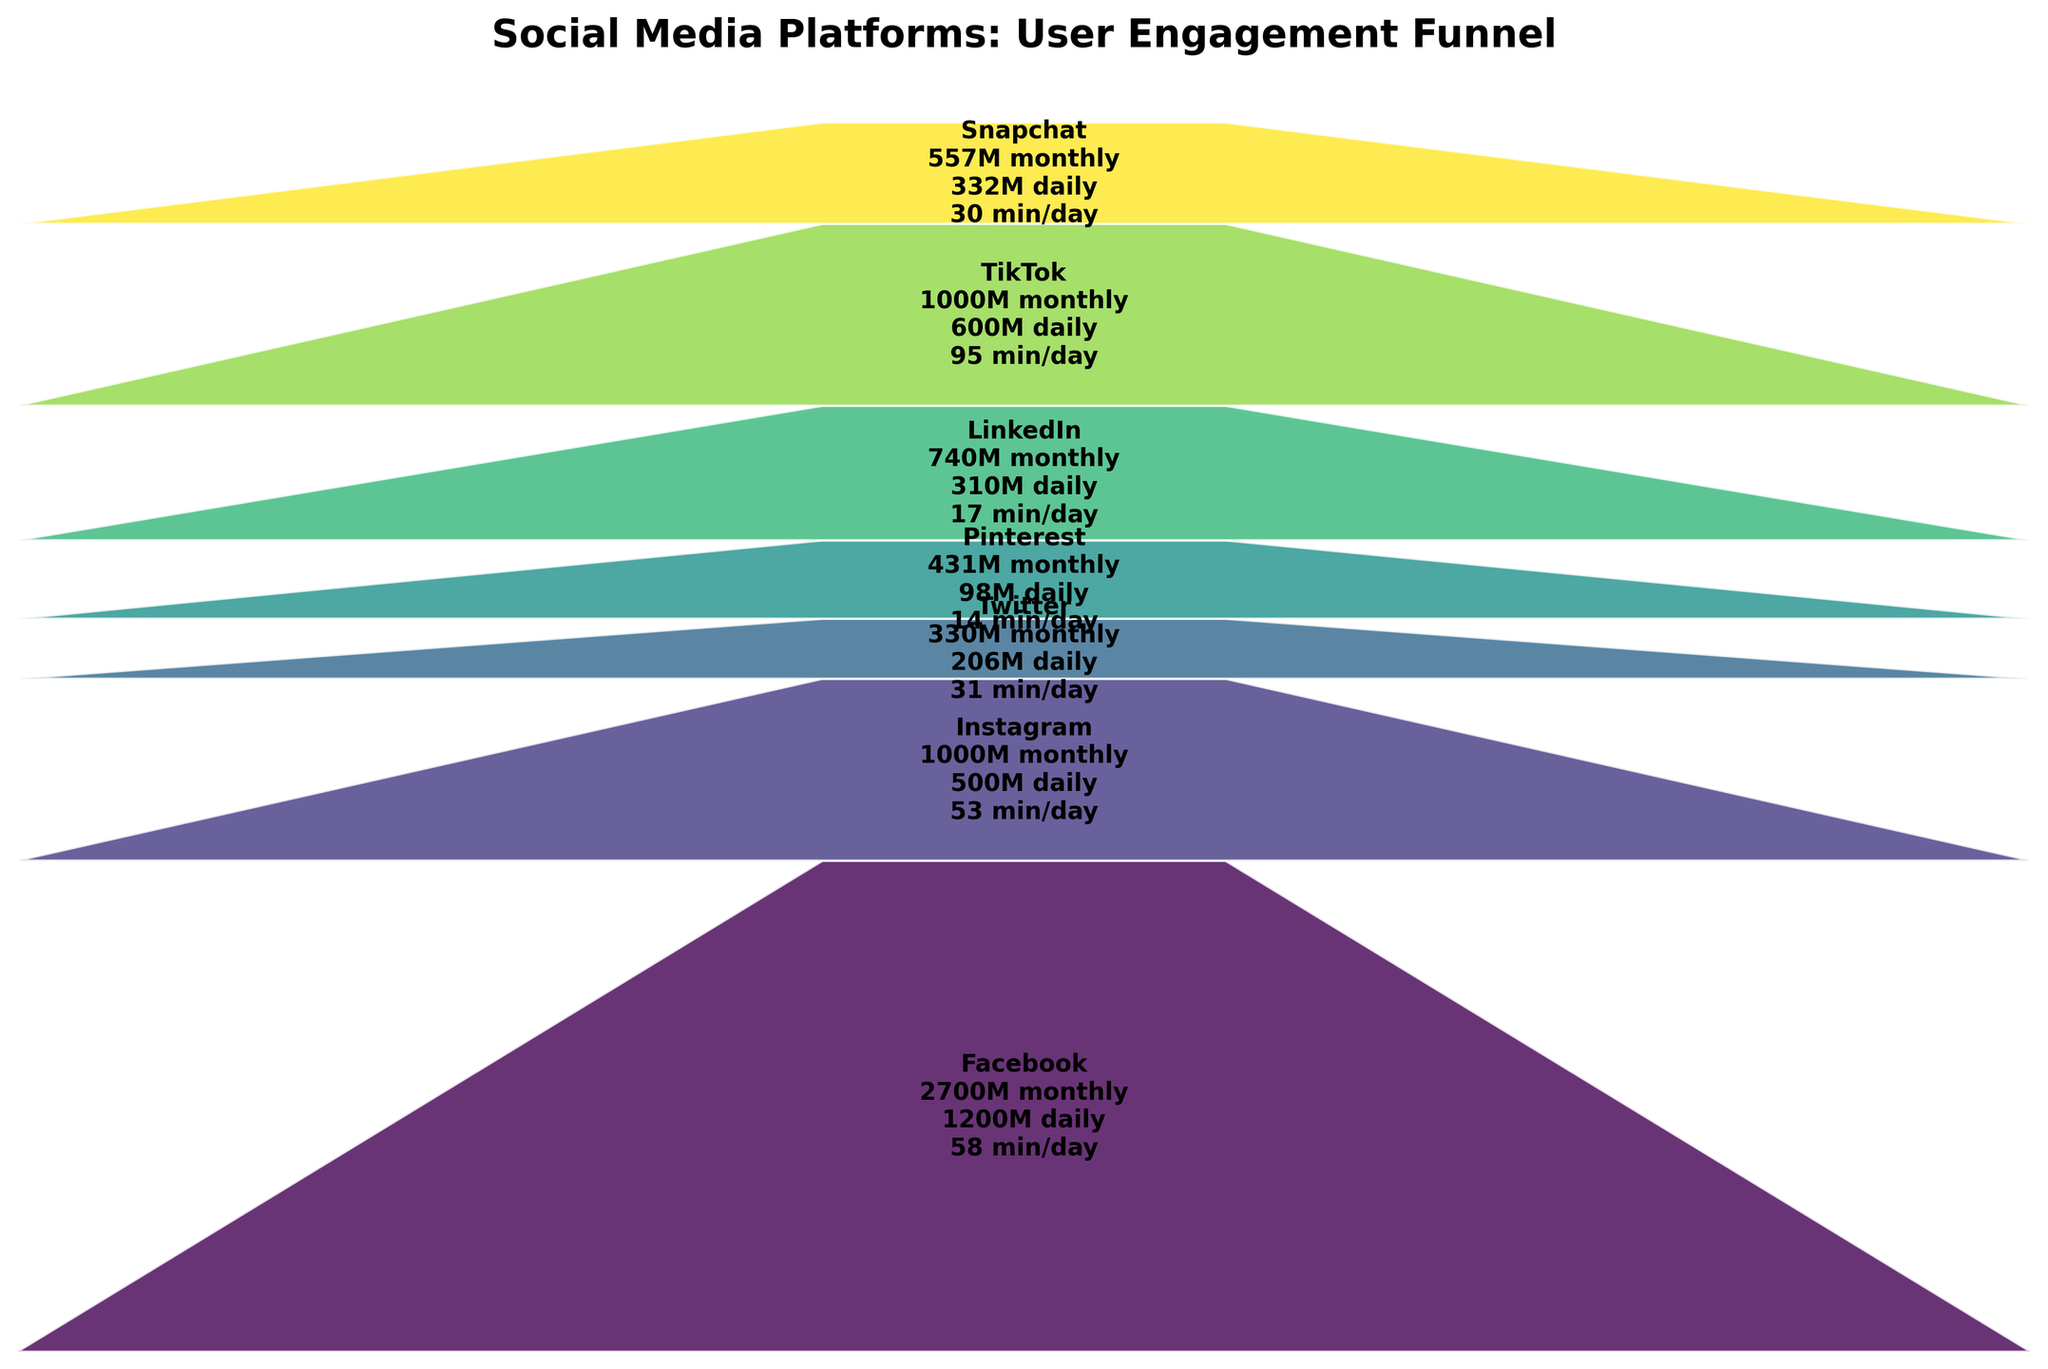What is the title of the funnel chart? The title of the funnel chart appears at the top of the chart. By looking at the top section, we can read the title.
Answer: Social Media Platforms: User Engagement Funnel Which platform has the highest time spent per day? By looking at the segment that displays the time spent per day for each platform, one can see that TikTok has the highest value listed at 95 minutes.
Answer: TikTok How many platforms have more than 500 million monthly active users? By examining the number of monthly active users displayed inside each segment, we can count how many platforms have values greater than 500 million. Facebook, Instagram, TikTok, and Snapchat meet this criterion.
Answer: 4 Which social media platform has the lowest monthly active users and what is the value? By comparing the numbers shown for the monthly active users, we see that Pinterest has the lowest value with 431 million.
Answer: Pinterest with 431 million Compare the daily active users of Snapchat and Twitter. Which one is higher and by how much? Examine the daily active users for both Snapchat and Twitter. Snapchat has 332 million while Twitter has 206 million. Subtract Twitter's users from Snapchat's to find the difference: 332 - 206 = 126.
Answer: Snapchat is higher by 126 million What is the total number of daily active users for all platforms combined? Add up the figures for daily active users displayed for each platform: 1200 (Facebook) + 500 (Instagram) + 206 (Twitter) + 98 (Pinterest) + 310 (LinkedIn) + 600 (TikTok) + 332 (Snapchat) = 3246 million.
Answer: 3246 million Which platform has a greater daily to monthly active user ratio: Instagram or LinkedIn? To find the ratio, we need to divide daily users by monthly users for each platform. For Instagram: 500/1000 = 0.5. For LinkedIn: 310/740 ≈ 0.419. Instagram’s ratio is greater.
Answer: Instagram What is the average time spent per day across all platforms? Sum the time spent for each platform and divide by the number of platforms: (58 + 53 + 31 + 14 + 17 + 95 + 30) / 7 ≈ 298 / 7 ≈ 42.57.
Answer: Approximately 42.57 minutes Which two platforms have the most similar time spent per day values? Comparing the time spent per day for each platform, we notice that Facebook (58 minutes) and Instagram (53 minutes) have the most similar values, with a difference of just 5 minutes.
Answer: Facebook and Instagram 